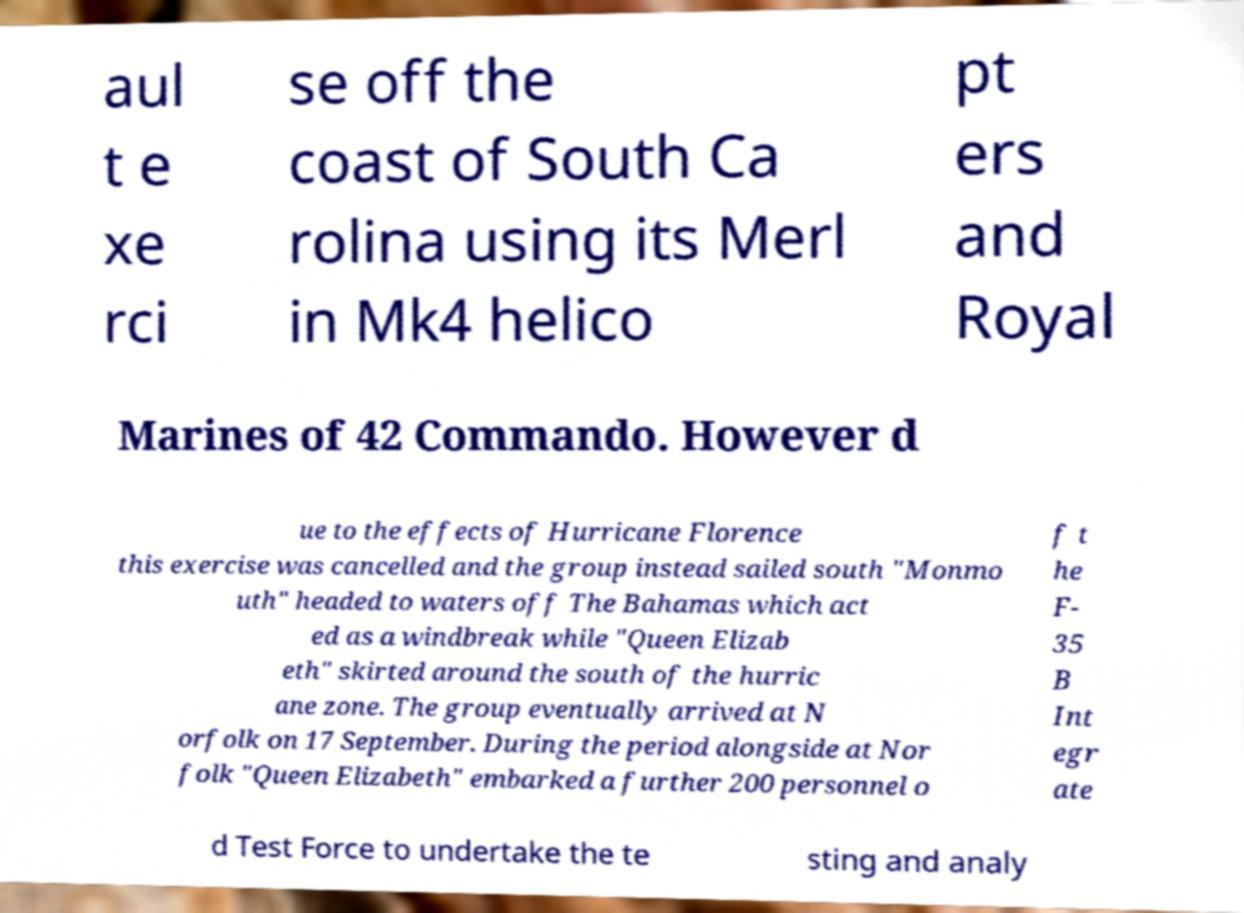Can you accurately transcribe the text from the provided image for me? aul t e xe rci se off the coast of South Ca rolina using its Merl in Mk4 helico pt ers and Royal Marines of 42 Commando. However d ue to the effects of Hurricane Florence this exercise was cancelled and the group instead sailed south "Monmo uth" headed to waters off The Bahamas which act ed as a windbreak while "Queen Elizab eth" skirted around the south of the hurric ane zone. The group eventually arrived at N orfolk on 17 September. During the period alongside at Nor folk "Queen Elizabeth" embarked a further 200 personnel o f t he F- 35 B Int egr ate d Test Force to undertake the te sting and analy 